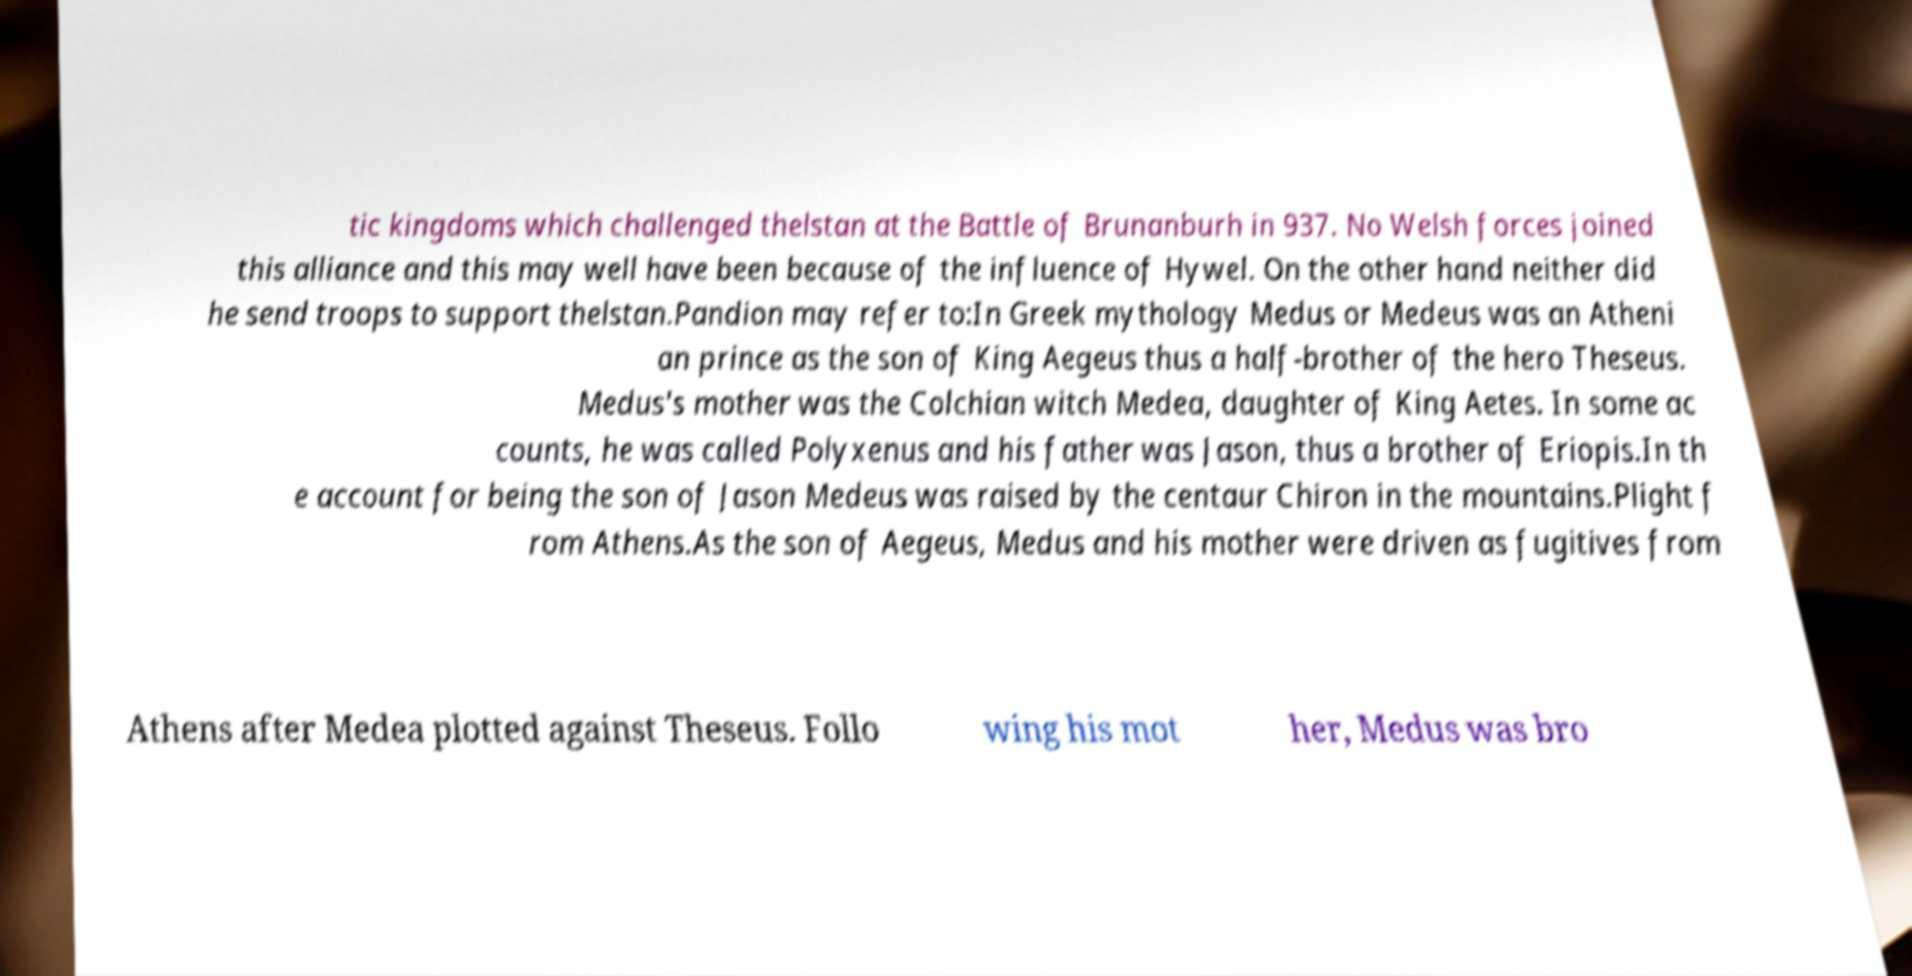Please read and relay the text visible in this image. What does it say? tic kingdoms which challenged thelstan at the Battle of Brunanburh in 937. No Welsh forces joined this alliance and this may well have been because of the influence of Hywel. On the other hand neither did he send troops to support thelstan.Pandion may refer to:In Greek mythology Medus or Medeus was an Atheni an prince as the son of King Aegeus thus a half-brother of the hero Theseus. Medus's mother was the Colchian witch Medea, daughter of King Aetes. In some ac counts, he was called Polyxenus and his father was Jason, thus a brother of Eriopis.In th e account for being the son of Jason Medeus was raised by the centaur Chiron in the mountains.Plight f rom Athens.As the son of Aegeus, Medus and his mother were driven as fugitives from Athens after Medea plotted against Theseus. Follo wing his mot her, Medus was bro 